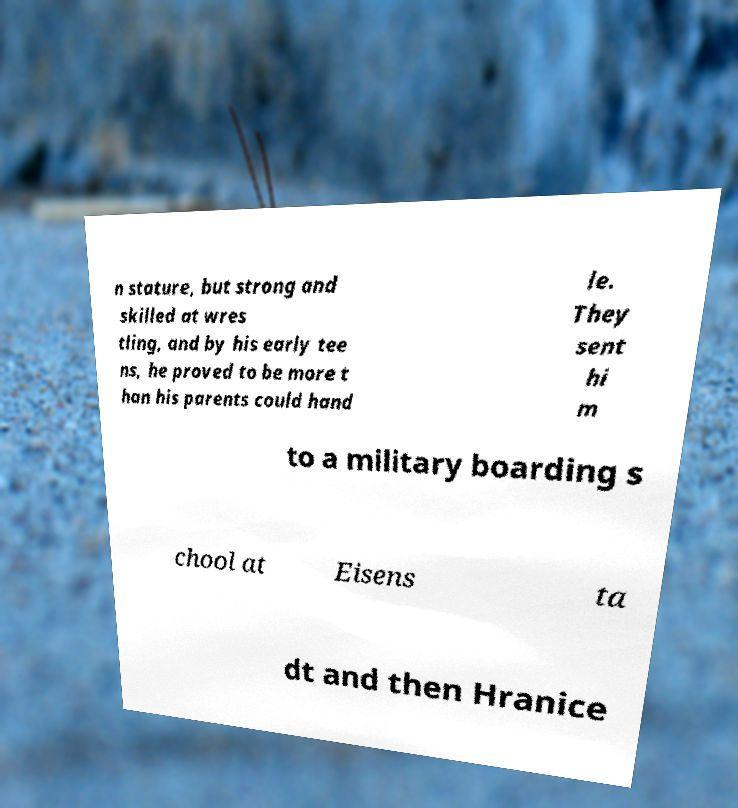For documentation purposes, I need the text within this image transcribed. Could you provide that? n stature, but strong and skilled at wres tling, and by his early tee ns, he proved to be more t han his parents could hand le. They sent hi m to a military boarding s chool at Eisens ta dt and then Hranice 